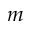Convert formula to latex. <formula><loc_0><loc_0><loc_500><loc_500>m</formula> 